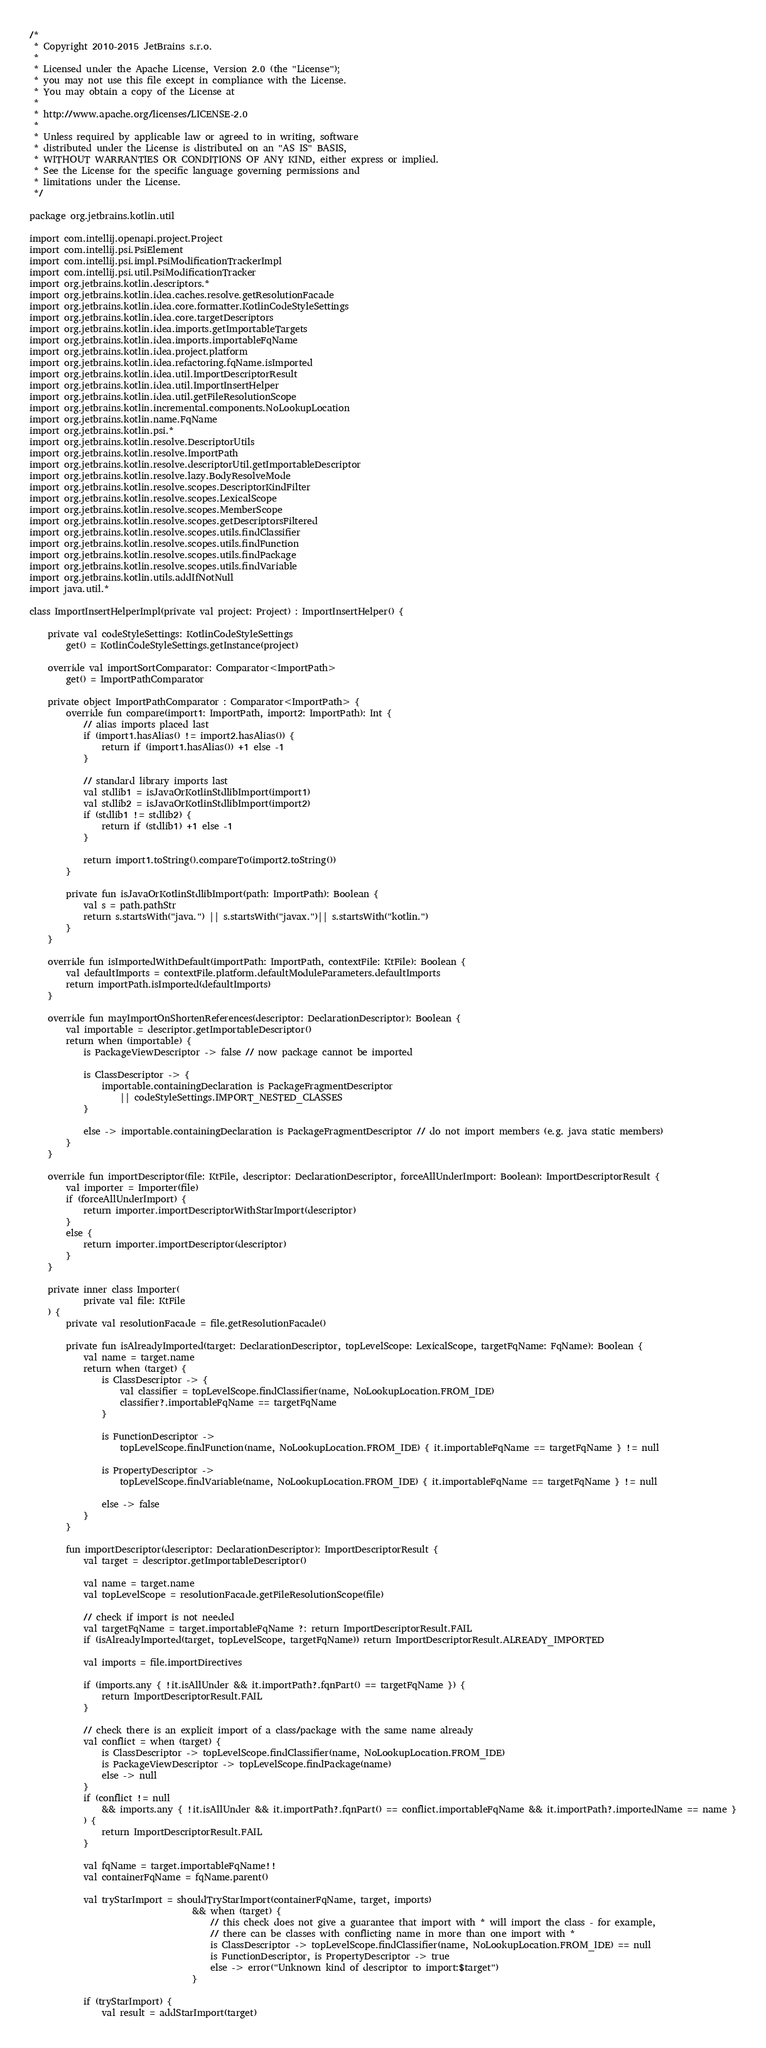<code> <loc_0><loc_0><loc_500><loc_500><_Kotlin_>/*
 * Copyright 2010-2015 JetBrains s.r.o.
 *
 * Licensed under the Apache License, Version 2.0 (the "License");
 * you may not use this file except in compliance with the License.
 * You may obtain a copy of the License at
 *
 * http://www.apache.org/licenses/LICENSE-2.0
 *
 * Unless required by applicable law or agreed to in writing, software
 * distributed under the License is distributed on an "AS IS" BASIS,
 * WITHOUT WARRANTIES OR CONDITIONS OF ANY KIND, either express or implied.
 * See the License for the specific language governing permissions and
 * limitations under the License.
 */

package org.jetbrains.kotlin.util

import com.intellij.openapi.project.Project
import com.intellij.psi.PsiElement
import com.intellij.psi.impl.PsiModificationTrackerImpl
import com.intellij.psi.util.PsiModificationTracker
import org.jetbrains.kotlin.descriptors.*
import org.jetbrains.kotlin.idea.caches.resolve.getResolutionFacade
import org.jetbrains.kotlin.idea.core.formatter.KotlinCodeStyleSettings
import org.jetbrains.kotlin.idea.core.targetDescriptors
import org.jetbrains.kotlin.idea.imports.getImportableTargets
import org.jetbrains.kotlin.idea.imports.importableFqName
import org.jetbrains.kotlin.idea.project.platform
import org.jetbrains.kotlin.idea.refactoring.fqName.isImported
import org.jetbrains.kotlin.idea.util.ImportDescriptorResult
import org.jetbrains.kotlin.idea.util.ImportInsertHelper
import org.jetbrains.kotlin.idea.util.getFileResolutionScope
import org.jetbrains.kotlin.incremental.components.NoLookupLocation
import org.jetbrains.kotlin.name.FqName
import org.jetbrains.kotlin.psi.*
import org.jetbrains.kotlin.resolve.DescriptorUtils
import org.jetbrains.kotlin.resolve.ImportPath
import org.jetbrains.kotlin.resolve.descriptorUtil.getImportableDescriptor
import org.jetbrains.kotlin.resolve.lazy.BodyResolveMode
import org.jetbrains.kotlin.resolve.scopes.DescriptorKindFilter
import org.jetbrains.kotlin.resolve.scopes.LexicalScope
import org.jetbrains.kotlin.resolve.scopes.MemberScope
import org.jetbrains.kotlin.resolve.scopes.getDescriptorsFiltered
import org.jetbrains.kotlin.resolve.scopes.utils.findClassifier
import org.jetbrains.kotlin.resolve.scopes.utils.findFunction
import org.jetbrains.kotlin.resolve.scopes.utils.findPackage
import org.jetbrains.kotlin.resolve.scopes.utils.findVariable
import org.jetbrains.kotlin.utils.addIfNotNull
import java.util.*

class ImportInsertHelperImpl(private val project: Project) : ImportInsertHelper() {

    private val codeStyleSettings: KotlinCodeStyleSettings
        get() = KotlinCodeStyleSettings.getInstance(project)

    override val importSortComparator: Comparator<ImportPath>
        get() = ImportPathComparator

    private object ImportPathComparator : Comparator<ImportPath> {
        override fun compare(import1: ImportPath, import2: ImportPath): Int {
            // alias imports placed last
            if (import1.hasAlias() != import2.hasAlias()) {
                return if (import1.hasAlias()) +1 else -1
            }

            // standard library imports last
            val stdlib1 = isJavaOrKotlinStdlibImport(import1)
            val stdlib2 = isJavaOrKotlinStdlibImport(import2)
            if (stdlib1 != stdlib2) {
                return if (stdlib1) +1 else -1
            }

            return import1.toString().compareTo(import2.toString())
        }

        private fun isJavaOrKotlinStdlibImport(path: ImportPath): Boolean {
            val s = path.pathStr
            return s.startsWith("java.") || s.startsWith("javax.")|| s.startsWith("kotlin.")
        }
    }

    override fun isImportedWithDefault(importPath: ImportPath, contextFile: KtFile): Boolean {
        val defaultImports = contextFile.platform.defaultModuleParameters.defaultImports
        return importPath.isImported(defaultImports)
    }

    override fun mayImportOnShortenReferences(descriptor: DeclarationDescriptor): Boolean {
        val importable = descriptor.getImportableDescriptor()
        return when (importable) {
            is PackageViewDescriptor -> false // now package cannot be imported

            is ClassDescriptor -> {
                importable.containingDeclaration is PackageFragmentDescriptor
                    || codeStyleSettings.IMPORT_NESTED_CLASSES
            }

            else -> importable.containingDeclaration is PackageFragmentDescriptor // do not import members (e.g. java static members)
        }
    }

    override fun importDescriptor(file: KtFile, descriptor: DeclarationDescriptor, forceAllUnderImport: Boolean): ImportDescriptorResult {
        val importer = Importer(file)
        if (forceAllUnderImport) {
            return importer.importDescriptorWithStarImport(descriptor)
        }
        else {
            return importer.importDescriptor(descriptor)
        }
    }

    private inner class Importer(
            private val file: KtFile
    ) {
        private val resolutionFacade = file.getResolutionFacade()

        private fun isAlreadyImported(target: DeclarationDescriptor, topLevelScope: LexicalScope, targetFqName: FqName): Boolean {
            val name = target.name
            return when (target) {
                is ClassDescriptor -> {
                    val classifier = topLevelScope.findClassifier(name, NoLookupLocation.FROM_IDE)
                    classifier?.importableFqName == targetFqName
                }

                is FunctionDescriptor ->
                    topLevelScope.findFunction(name, NoLookupLocation.FROM_IDE) { it.importableFqName == targetFqName } != null

                is PropertyDescriptor ->
                    topLevelScope.findVariable(name, NoLookupLocation.FROM_IDE) { it.importableFqName == targetFqName } != null

                else -> false
            }
        }

        fun importDescriptor(descriptor: DeclarationDescriptor): ImportDescriptorResult {
            val target = descriptor.getImportableDescriptor()

            val name = target.name
            val topLevelScope = resolutionFacade.getFileResolutionScope(file)

            // check if import is not needed
            val targetFqName = target.importableFqName ?: return ImportDescriptorResult.FAIL
            if (isAlreadyImported(target, topLevelScope, targetFqName)) return ImportDescriptorResult.ALREADY_IMPORTED

            val imports = file.importDirectives

            if (imports.any { !it.isAllUnder && it.importPath?.fqnPart() == targetFqName }) {
                return ImportDescriptorResult.FAIL
            }

            // check there is an explicit import of a class/package with the same name already
            val conflict = when (target) {
                is ClassDescriptor -> topLevelScope.findClassifier(name, NoLookupLocation.FROM_IDE)
                is PackageViewDescriptor -> topLevelScope.findPackage(name)
                else -> null
            }
            if (conflict != null
                && imports.any { !it.isAllUnder && it.importPath?.fqnPart() == conflict.importableFqName && it.importPath?.importedName == name }
            ) {
                return ImportDescriptorResult.FAIL
            }

            val fqName = target.importableFqName!!
            val containerFqName = fqName.parent()

            val tryStarImport = shouldTryStarImport(containerFqName, target, imports)
                                    && when (target) {
                                        // this check does not give a guarantee that import with * will import the class - for example,
                                        // there can be classes with conflicting name in more than one import with *
                                        is ClassDescriptor -> topLevelScope.findClassifier(name, NoLookupLocation.FROM_IDE) == null
                                        is FunctionDescriptor, is PropertyDescriptor -> true
                                        else -> error("Unknown kind of descriptor to import:$target")
                                    }

            if (tryStarImport) {
                val result = addStarImport(target)</code> 